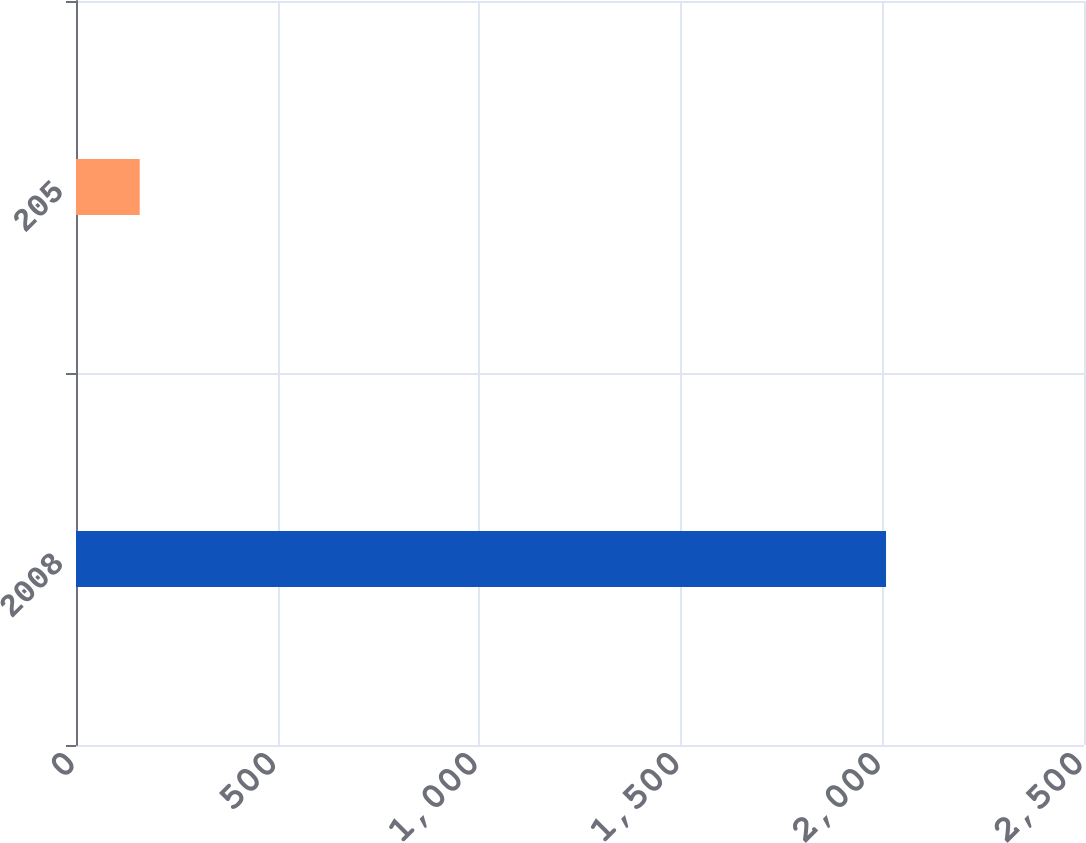Convert chart. <chart><loc_0><loc_0><loc_500><loc_500><bar_chart><fcel>2008<fcel>205<nl><fcel>2009<fcel>158<nl></chart> 